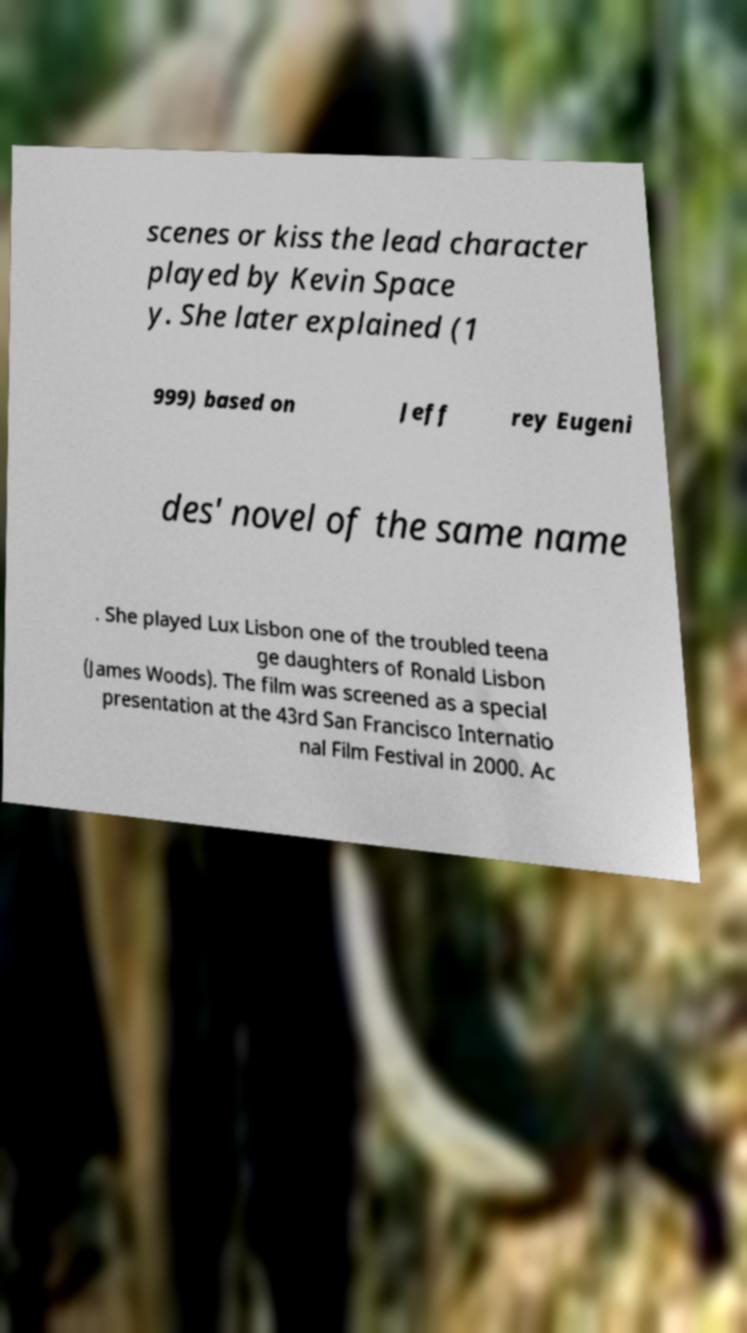I need the written content from this picture converted into text. Can you do that? scenes or kiss the lead character played by Kevin Space y. She later explained (1 999) based on Jeff rey Eugeni des' novel of the same name . She played Lux Lisbon one of the troubled teena ge daughters of Ronald Lisbon (James Woods). The film was screened as a special presentation at the 43rd San Francisco Internatio nal Film Festival in 2000. Ac 